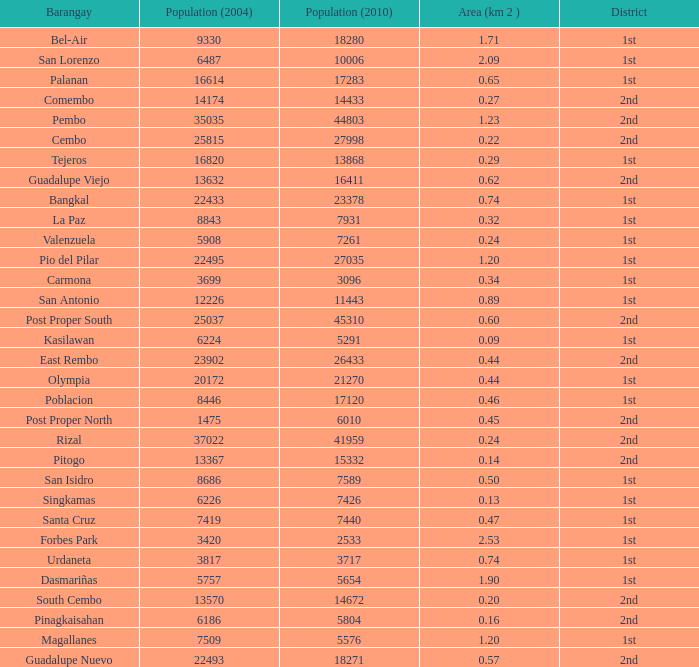What is the area where barangay is guadalupe viejo? 0.62. 